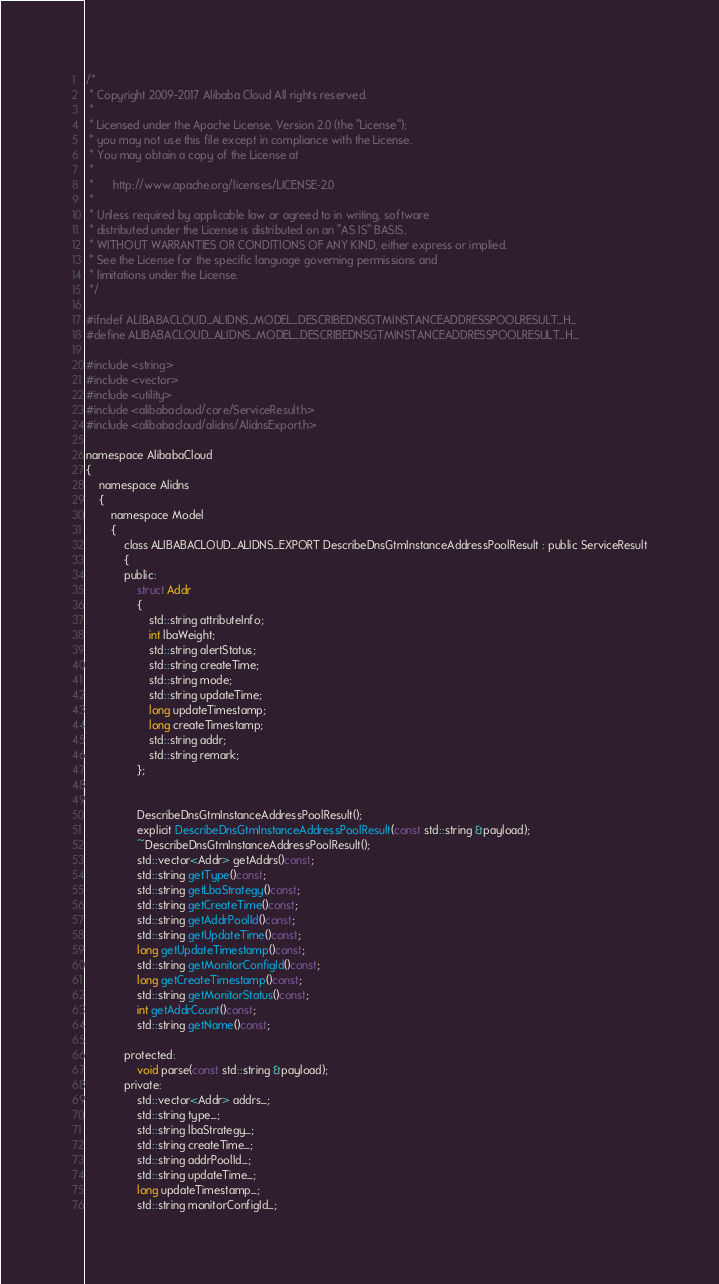Convert code to text. <code><loc_0><loc_0><loc_500><loc_500><_C_>/*
 * Copyright 2009-2017 Alibaba Cloud All rights reserved.
 * 
 * Licensed under the Apache License, Version 2.0 (the "License");
 * you may not use this file except in compliance with the License.
 * You may obtain a copy of the License at
 * 
 *      http://www.apache.org/licenses/LICENSE-2.0
 * 
 * Unless required by applicable law or agreed to in writing, software
 * distributed under the License is distributed on an "AS IS" BASIS,
 * WITHOUT WARRANTIES OR CONDITIONS OF ANY KIND, either express or implied.
 * See the License for the specific language governing permissions and
 * limitations under the License.
 */

#ifndef ALIBABACLOUD_ALIDNS_MODEL_DESCRIBEDNSGTMINSTANCEADDRESSPOOLRESULT_H_
#define ALIBABACLOUD_ALIDNS_MODEL_DESCRIBEDNSGTMINSTANCEADDRESSPOOLRESULT_H_

#include <string>
#include <vector>
#include <utility>
#include <alibabacloud/core/ServiceResult.h>
#include <alibabacloud/alidns/AlidnsExport.h>

namespace AlibabaCloud
{
	namespace Alidns
	{
		namespace Model
		{
			class ALIBABACLOUD_ALIDNS_EXPORT DescribeDnsGtmInstanceAddressPoolResult : public ServiceResult
			{
			public:
				struct Addr
				{
					std::string attributeInfo;
					int lbaWeight;
					std::string alertStatus;
					std::string createTime;
					std::string mode;
					std::string updateTime;
					long updateTimestamp;
					long createTimestamp;
					std::string addr;
					std::string remark;
				};


				DescribeDnsGtmInstanceAddressPoolResult();
				explicit DescribeDnsGtmInstanceAddressPoolResult(const std::string &payload);
				~DescribeDnsGtmInstanceAddressPoolResult();
				std::vector<Addr> getAddrs()const;
				std::string getType()const;
				std::string getLbaStrategy()const;
				std::string getCreateTime()const;
				std::string getAddrPoolId()const;
				std::string getUpdateTime()const;
				long getUpdateTimestamp()const;
				std::string getMonitorConfigId()const;
				long getCreateTimestamp()const;
				std::string getMonitorStatus()const;
				int getAddrCount()const;
				std::string getName()const;

			protected:
				void parse(const std::string &payload);
			private:
				std::vector<Addr> addrs_;
				std::string type_;
				std::string lbaStrategy_;
				std::string createTime_;
				std::string addrPoolId_;
				std::string updateTime_;
				long updateTimestamp_;
				std::string monitorConfigId_;</code> 